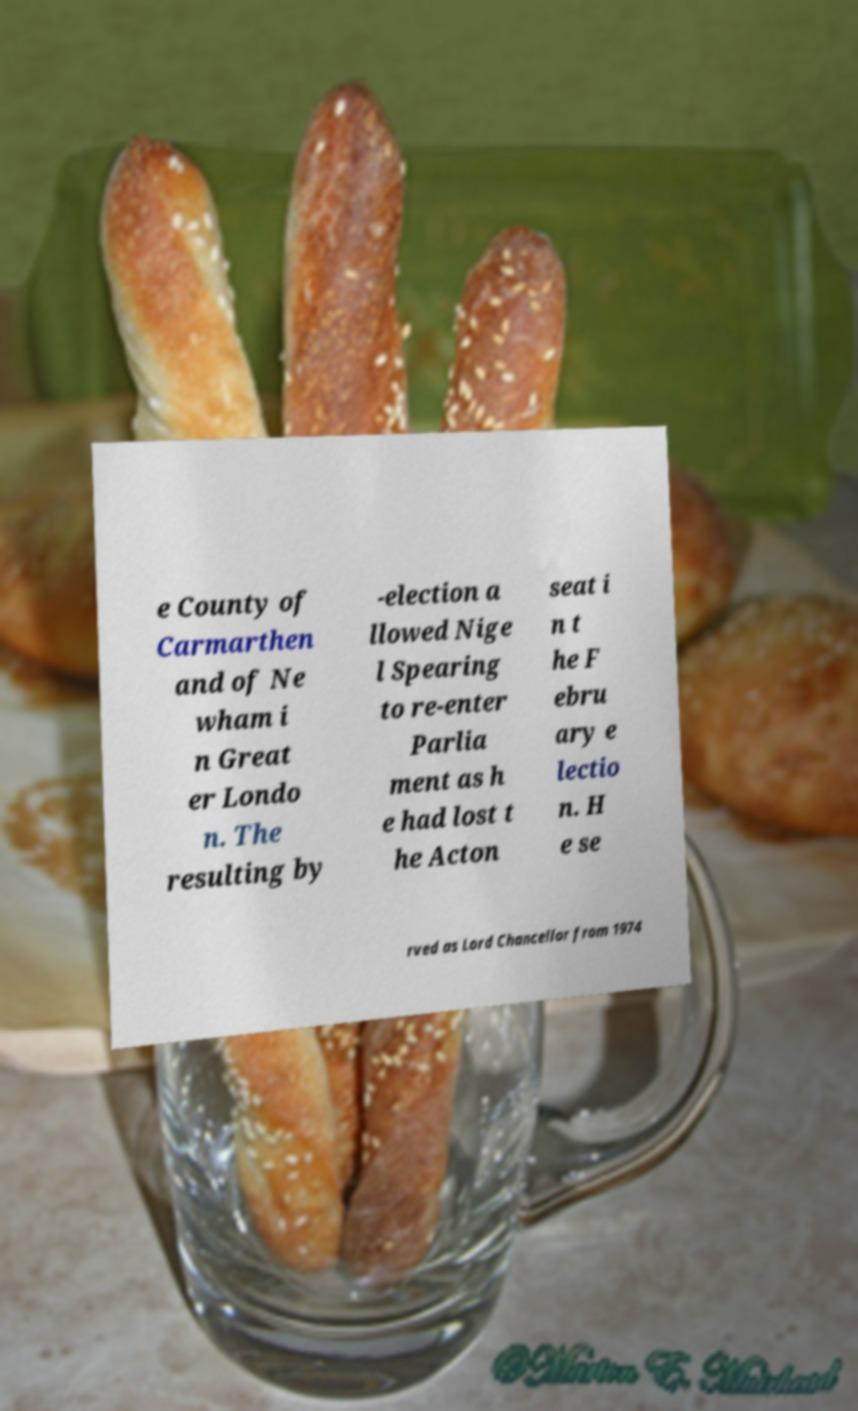Could you extract and type out the text from this image? e County of Carmarthen and of Ne wham i n Great er Londo n. The resulting by -election a llowed Nige l Spearing to re-enter Parlia ment as h e had lost t he Acton seat i n t he F ebru ary e lectio n. H e se rved as Lord Chancellor from 1974 